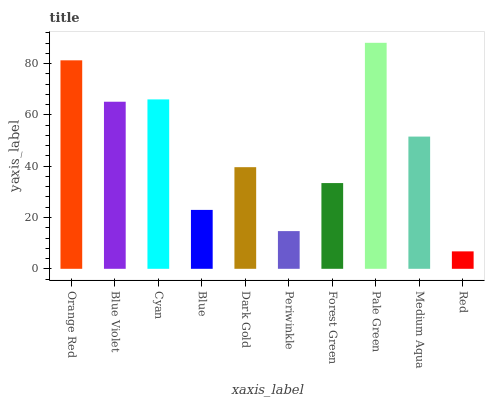Is Red the minimum?
Answer yes or no. Yes. Is Pale Green the maximum?
Answer yes or no. Yes. Is Blue Violet the minimum?
Answer yes or no. No. Is Blue Violet the maximum?
Answer yes or no. No. Is Orange Red greater than Blue Violet?
Answer yes or no. Yes. Is Blue Violet less than Orange Red?
Answer yes or no. Yes. Is Blue Violet greater than Orange Red?
Answer yes or no. No. Is Orange Red less than Blue Violet?
Answer yes or no. No. Is Medium Aqua the high median?
Answer yes or no. Yes. Is Dark Gold the low median?
Answer yes or no. Yes. Is Orange Red the high median?
Answer yes or no. No. Is Red the low median?
Answer yes or no. No. 